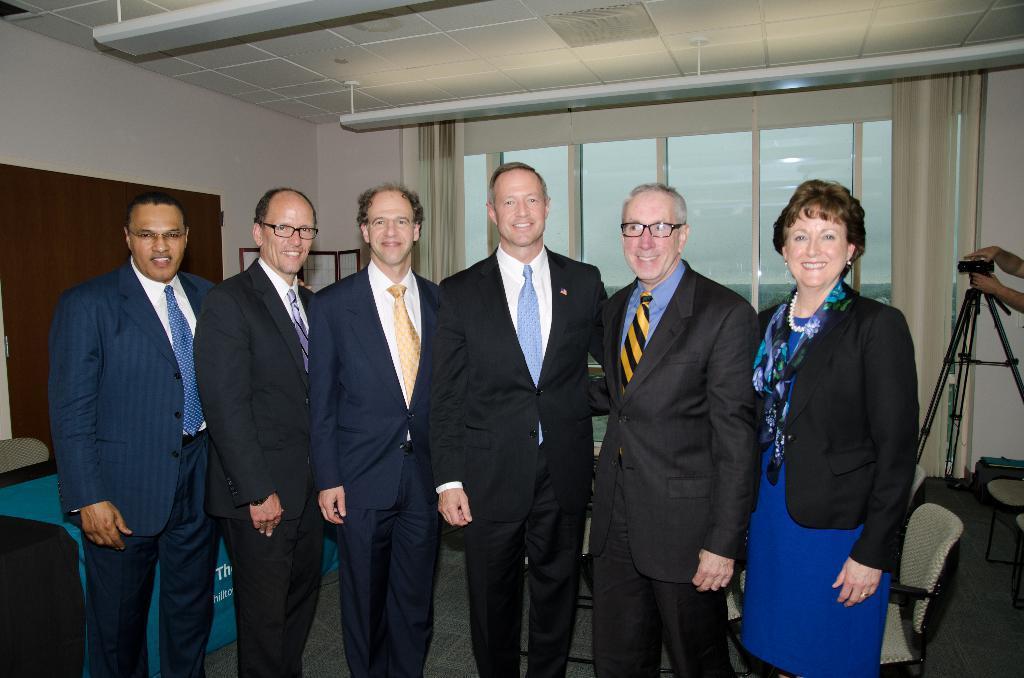How would you summarize this image in a sentence or two? In this image there are group of people who are posing for the picture. At the top there is ceiling with the lights. In the background there are windows with a curtain beside it. Behind them there are chairs. On the right side there is a tripod on which there is a camera. 